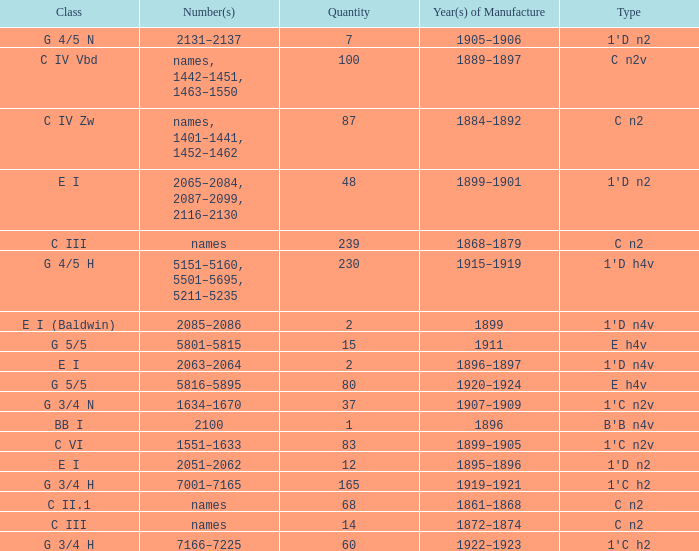Which Class has a Year(s) of Manufacture of 1899? E I (Baldwin). 